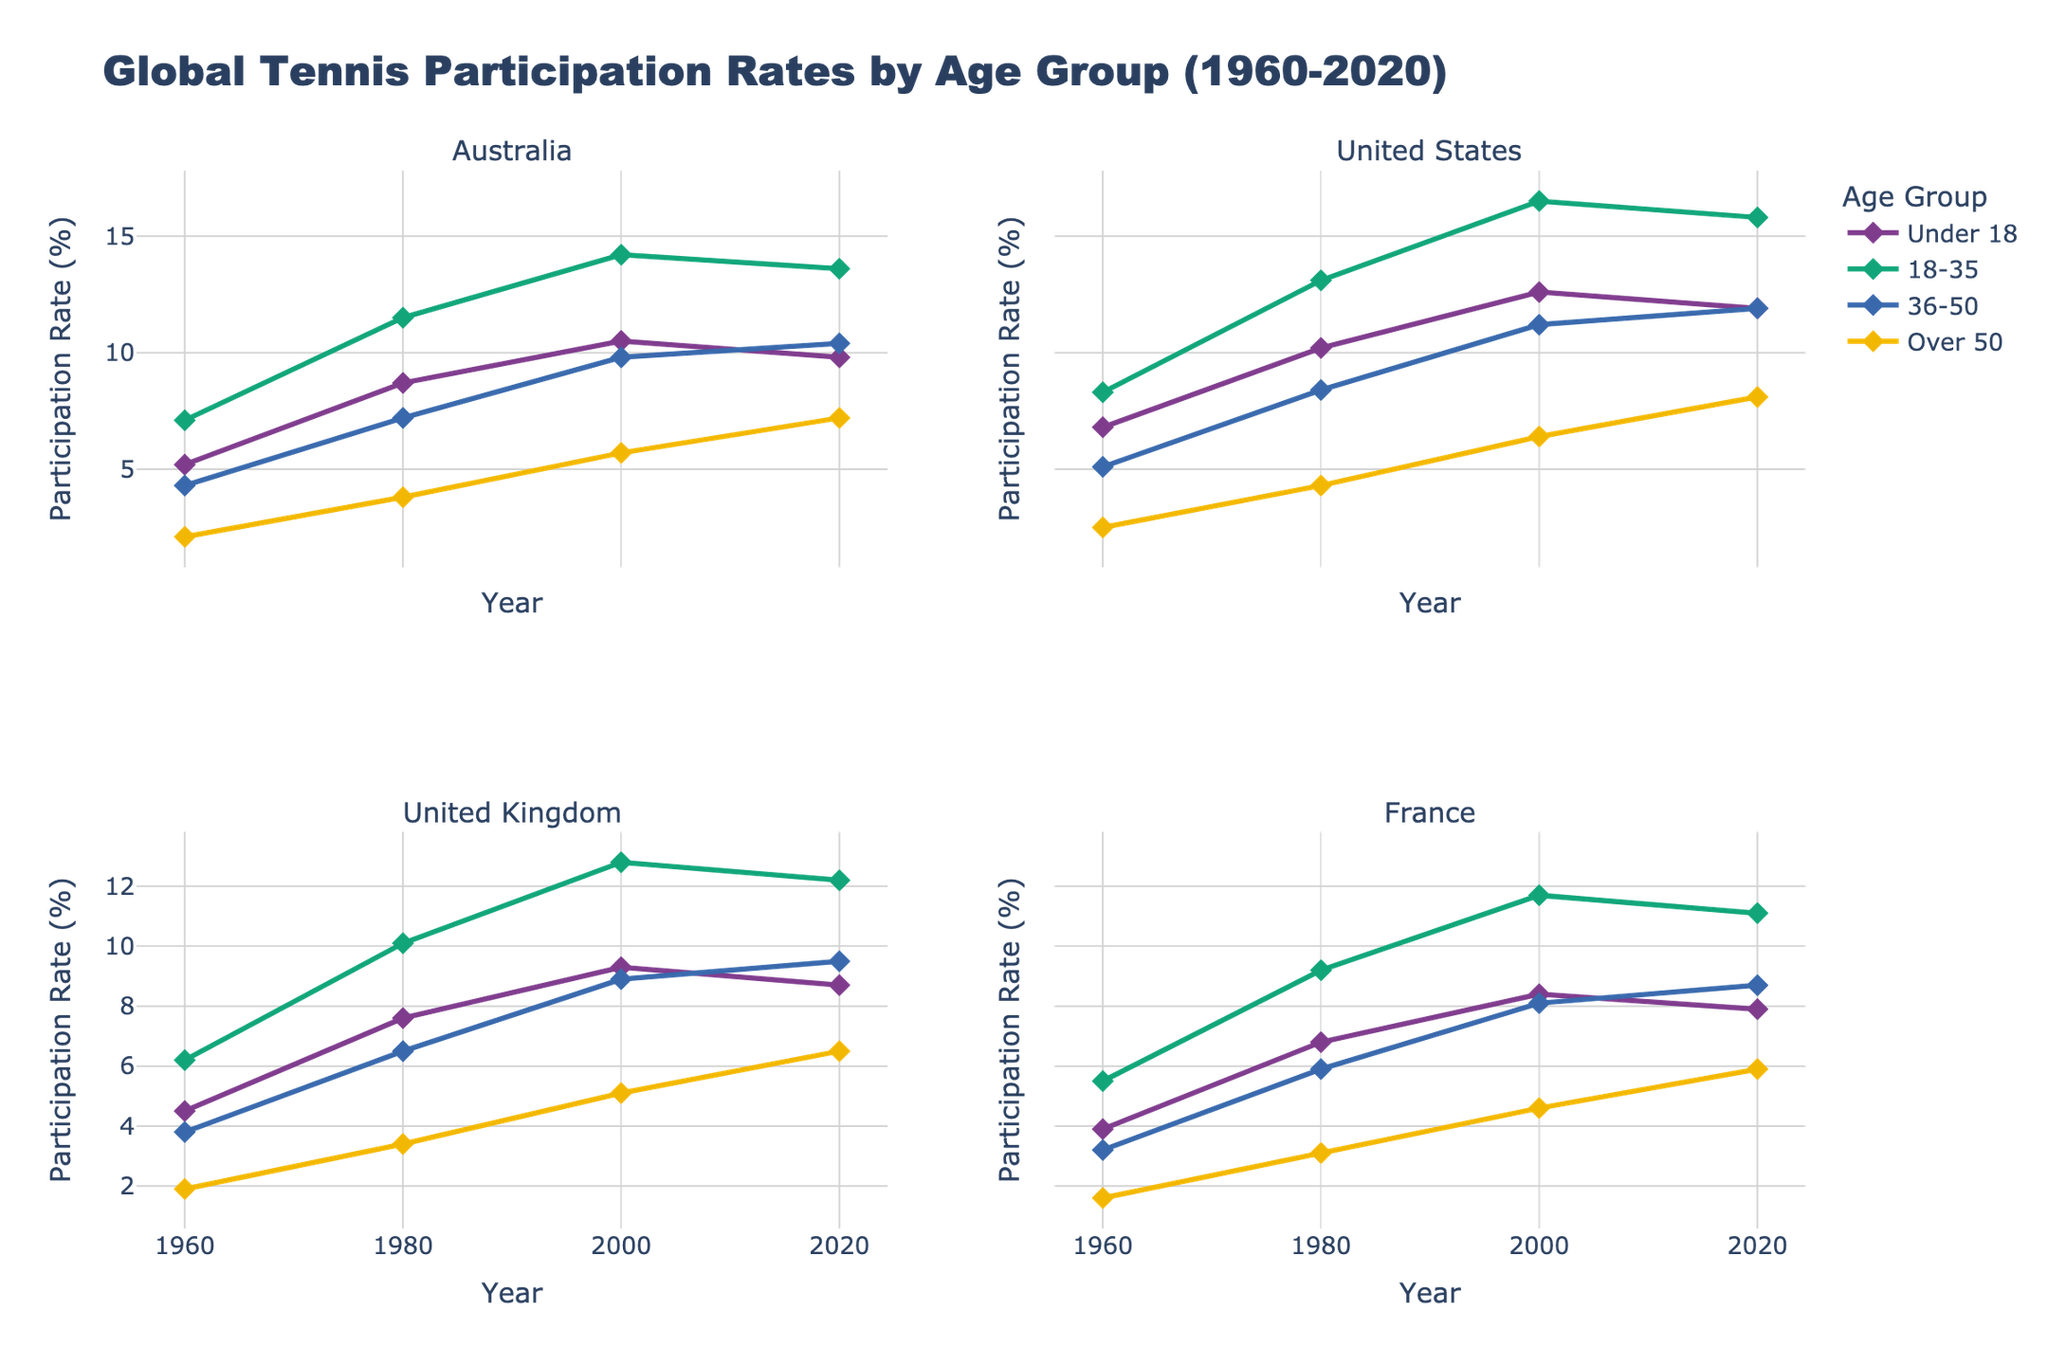Which age group has the highest participation rate in Australia in 2020? Look at the subplot for Australia and find the line representing the highest value in 2020. The line with the highest participation rate is the "18-35" age group. This can be verified by comparing the y-values of the various age group lines intersecting at 2020, where the 18-35 line is the highest.
Answer: 18-35 How did the participation rate for the "Under 18" age group in the United States change from 1960 to 2020? Refer to the subplot for the United States. Trace the "Under 18" line from 1960 to 2020. In 1960, the value is 6.8%, and it increases to 11.9% in 2020. Therefore, it increased by 5.1%.
Answer: Increased by 5.1% Which country experienced the largest increase in participation rate for the "Over 50" age group between 1960 and 2020? Compare the "Over 50" lines across all four subplots (Australia, United States, United Kingdom, France). For each country, compute the difference between the 1960 and 2020 values. The country with the largest increase is France, with an increase from 1.6% in 1960 to 5.9% in 2020, resulting in an increase of 4.3%.
Answer: France Among the four countries, which had the highest participation rate for the "18-35" age group in 1980? Go to each subplot and check the y-value of the "18-35" line at the year 1980. The subplot for the United States shows the highest participation rate of 13.1% among the four countries.
Answer: United States What is the trend pattern observed in the "36-50" age group for the United Kingdom from 1960 to 2020? Examine the subplot for the United Kingdom and look at the "36-50" line. The pattern generally trends upwards from 1960 (3.8%) to 2020 (9.5%), indicating a consistent increase in participation rate over time.
Answer: Increasing trend How do the participation rates for the "Over 50" age group in France compare between 1960 and 2020? Look at the subplot for France and locate the "Over 50" points at 1960 and 2020. The participation rate increased from 1.6% in 1960 to 5.9% in 2020.
Answer: Increased from 1.6% to 5.9% Which age group shows the largest participation rate in the United Kingdom in the year 2000? Refer to the subplot for the United Kingdom and check the highest point in the year 2000. The "18-35" age group shows the largest participation rate at 12.8%.
Answer: 18-35 What was the participation rate for the "Under 18" age group in Sweden in 1980? Check the line for the "Under 18" age group in the Sweden subplot at the 1980 point. The rate is 7.3%.
Answer: 7.3% Between which two consecutive decades did the "18-35" age group in Australia see the highest increase in participation rate? Look at the "18-35" line in the subplot for Australia and compare the increases between consecutive decades. The highest increase was from 18.35% to 14.2% from 1980 to 2000, which is an increase of 2.7%.
Answer: 1980 to 2000 